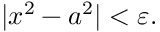Convert formula to latex. <formula><loc_0><loc_0><loc_500><loc_500>| x ^ { 2 } - a ^ { 2 } | < \varepsilon .</formula> 